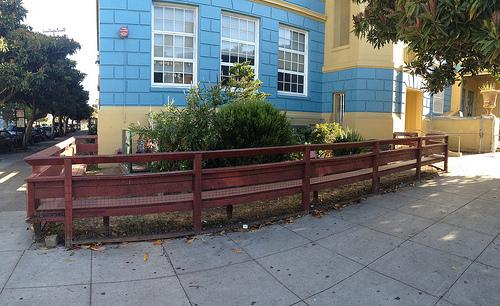Briefly describe the primary elements in the image, including the setting and flora. The setting is a pale yellow and light blue house with windows and a doorway, featuring a fence, leafy green trees, and bushes beside the building. Can you tell me the main architectural features of this image? There are large windows with white frames and multiple panes, a blue horizontal stripe, a tan bottom paint, wooden and wire fence, and a painted brick building. Describe the different fences shown in the image. The image contains a wooden and wire fence in a rusty brown color, and a part of a brown front-facing fence. What types of trees are visible in the image and their locations? There are green hanging leafy trees, low hanging branches of a green tree, and a row of medium height leafy green trees. Provide an overview of the image, focusing on the windows and their characteristics. The image showcases tall windows with white frames and twenty-four panes in multiple sizes, including large, middle, small, and window panes. Explain the landscape and nature elements in the picture. The image has green foliage, low hanging tree branches, row of medium height trees, bushy green shrubbery, and leaves along the walkway. In the image, what is the condition of the walkway and what are its features? The walkway is made of large quadrant stone tiles, and it has leaves scattered around it, along with a small orange leaf on the side. What type of plant-related decorations are seen in the picture? A large plant pot, a large potted plant, green hanging leafy trees, and a white stone pot design are seen in the image. Mention the main components of this image, including the building, fence, and plant decorations. The image features a painted brick house with large windows, a wooden and wire fence, plant pots, and green foliage in front of the house. Please give details about the exterior paint color of the building. The building is painted in pale yellow and light blue colors, with a tan color paint covering the bottom portion. 